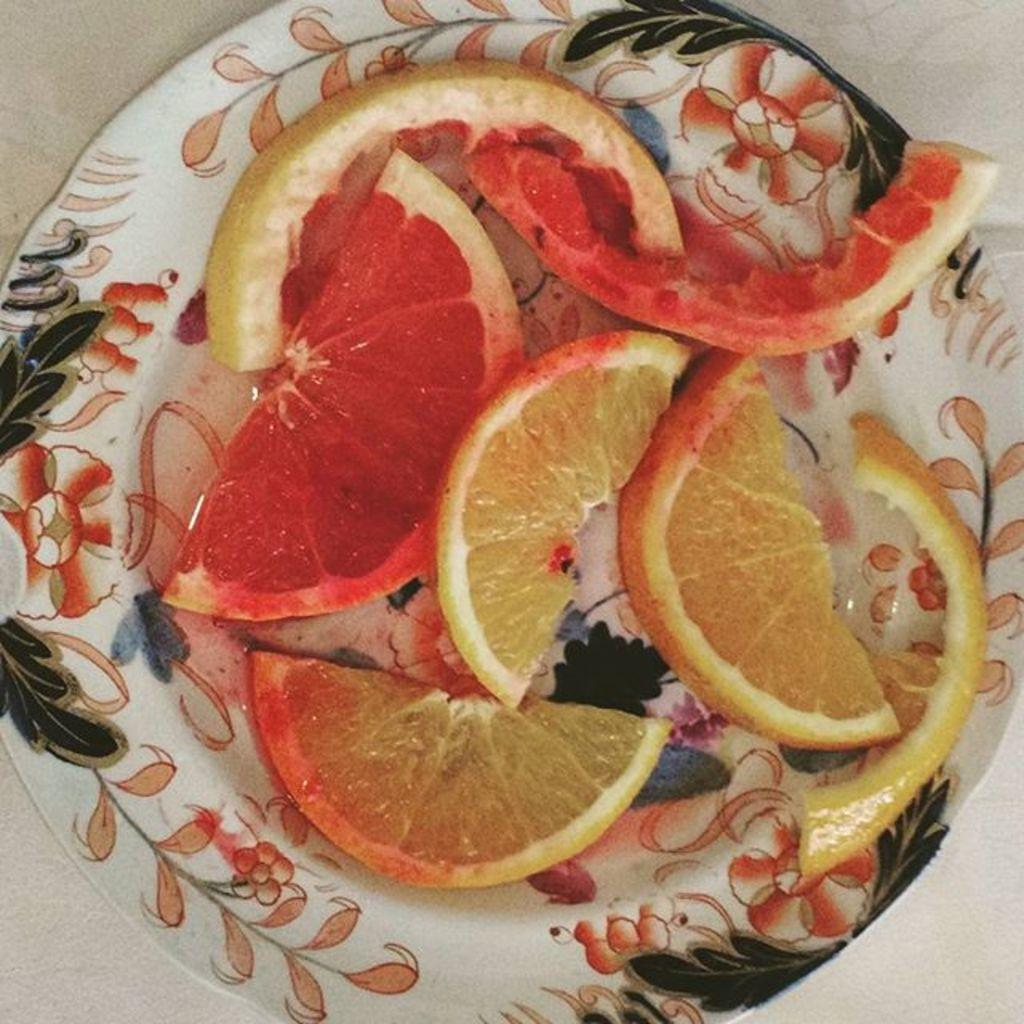How many dust particles can be seen in the recess during the hall meeting in the image? There is no information about a hall meeting, dust particles, or a recess in the image, so it is not possible to answer that question. 